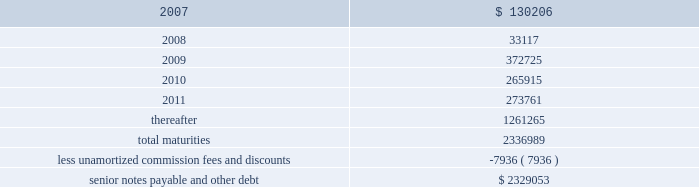Ventas , inc .
Notes to consolidated financial statements 2014 ( continued ) if we experience certain kinds of changes of control , the issuers must make an offer to repurchase the senior notes , in whole or in part , at a purchase price in cash equal to 101% ( 101 % ) of the principal amount of the senior notes , plus any accrued and unpaid interest to the date of purchase ; provided , however , that in the event moody 2019s and s&p have confirmed their ratings at ba3 or higher and bb- or higher on the senior notes and certain other conditions are met , this repurchase obligation will not apply .
Mortgages at december 31 , 2006 , we had outstanding 53 mortgage loans that we assumed in connection with various acquisitions .
Outstanding principal balances on these loans ranged from $ 0.4 million to $ 114.4 million as of december 31 , 2006 .
The loans bear interest at fixed rates ranging from 5.6% ( 5.6 % ) to 8.5% ( 8.5 % ) per annum , except with respect to eight loans with outstanding principal balances ranging from $ 0.4 million to $ 114.4 million , which bear interest at the lender 2019s variable rates , ranging from 3.6% ( 3.6 % ) to 8.5% ( 8.5 % ) per annum at of december 31 , 2006 .
The fixed rate debt bears interest at a weighted average annual rate of 7.06% ( 7.06 % ) and the variable rate debt bears interest at a weighted average annual rate of 5.61% ( 5.61 % ) as of december 31 , 2006 .
The loans had a weighted average maturity of eight years as of december 31 , 2006 .
The $ 114.4 variable mortgage debt was repaid in january 2007 .
Scheduled maturities of borrowing arrangements and other provisions as of december 31 , 2006 , our indebtedness has the following maturities ( in thousands ) : .
Certain provisions of our long-term debt contain covenants that limit our ability and the ability of certain of our subsidiaries to , among other things : ( i ) incur debt ; ( ii ) make certain dividends , distributions and investments ; ( iii ) enter into certain transactions ; ( iv ) merge , consolidate or transfer certain assets ; and ( v ) sell assets .
We and certain of our subsidiaries are also required to maintain total unencumbered assets of at least 150% ( 150 % ) of this group 2019s unsecured debt .
Derivatives and hedging in the normal course of business , we are exposed to the effect of interest rate changes .
We limit these risks by following established risk management policies and procedures including the use of derivatives .
For interest rate exposures , derivatives are used primarily to fix the rate on debt based on floating-rate indices and to manage the cost of borrowing obligations .
We currently have an interest rate swap to manage interest rate risk ( the 201cswap 201d ) .
We prohibit the use of derivative instruments for trading or speculative purposes .
Further , we have a policy of only entering into contracts with major financial institutions based upon their credit ratings and other factors .
When viewed in conjunction with the underlying and offsetting exposure that the derivative is designed to hedge , we do not anticipate any material adverse effect on our net income or financial position in the future from the use of derivatives. .
What percentage of total maturities were payable in 2011? 
Computations: (273761 / 2336989)
Answer: 0.11714. 